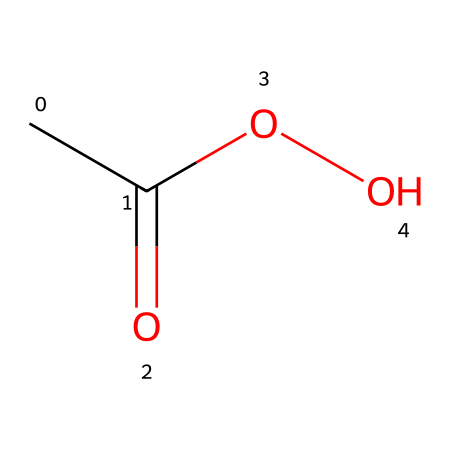What is the name of this chemical? The SMILES representation "CC(=O)OO" corresponds to a chemical known for its use as a sanitizer in food processing. This indicates that the compound is called peracetic acid.
Answer: peracetic acid How many carbon atoms are in this molecule? By examining the SMILES structure "CC(=O)OO," we can identify two carbon (C) atoms present in its molecular skeleton.
Answer: 2 What type of functional groups are present in peracetic acid? The structure includes both a carbonyl (C=O) group, which indicates the presence of a ketone, and a hydroxy (OH) group. Thus, the functional groups in peracetic acid are a carboxylic acid group and a peroxide linkage.
Answer: carboxylic acid, peroxide Which part of the molecule contributes to its oxidizing properties? The presence of the peroxide linkage (the -O-O- part) in the structure is what gives peracetic acid its strong oxidizing properties, making it effective as a sanitizer.
Answer: peroxide linkage What is the total number of oxygen atoms in this molecule? In the chemical structure represented by "CC(=O)OO," there are three oxygen (O) atoms identified: one in the carbonyl group and two in the hydroxy and peroxy groups combined.
Answer: 3 Is this chemical a stronger or weaker oxidizer compared to acetic acid? Peracetic acid is considered a stronger oxidizer than acetic acid, due to the additional oxygen in its peroxide bond which enhances its reactivity and disinfection effectiveness.
Answer: stronger 